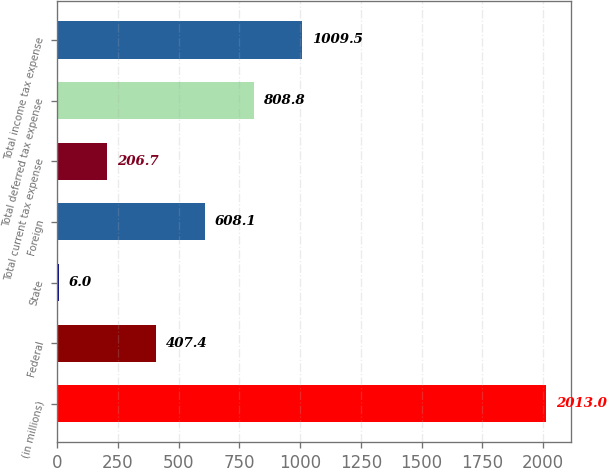<chart> <loc_0><loc_0><loc_500><loc_500><bar_chart><fcel>(in millions)<fcel>Federal<fcel>State<fcel>Foreign<fcel>Total current tax expense<fcel>Total deferred tax expense<fcel>Total income tax expense<nl><fcel>2013<fcel>407.4<fcel>6<fcel>608.1<fcel>206.7<fcel>808.8<fcel>1009.5<nl></chart> 